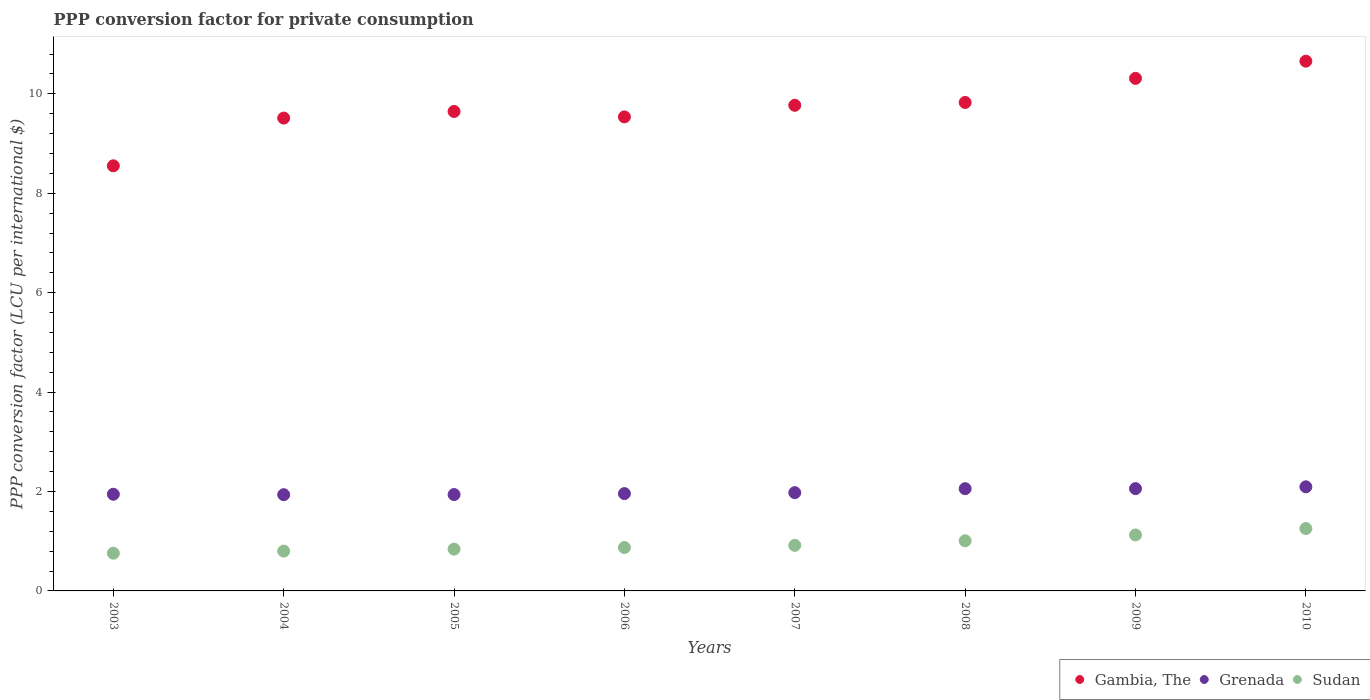How many different coloured dotlines are there?
Your answer should be compact. 3. Is the number of dotlines equal to the number of legend labels?
Offer a very short reply. Yes. What is the PPP conversion factor for private consumption in Sudan in 2008?
Provide a short and direct response. 1.01. Across all years, what is the maximum PPP conversion factor for private consumption in Gambia, The?
Offer a very short reply. 10.66. Across all years, what is the minimum PPP conversion factor for private consumption in Sudan?
Provide a short and direct response. 0.76. In which year was the PPP conversion factor for private consumption in Sudan minimum?
Your answer should be very brief. 2003. What is the total PPP conversion factor for private consumption in Grenada in the graph?
Give a very brief answer. 15.96. What is the difference between the PPP conversion factor for private consumption in Sudan in 2005 and that in 2008?
Your answer should be compact. -0.17. What is the difference between the PPP conversion factor for private consumption in Sudan in 2004 and the PPP conversion factor for private consumption in Grenada in 2008?
Your response must be concise. -1.26. What is the average PPP conversion factor for private consumption in Grenada per year?
Offer a very short reply. 2. In the year 2006, what is the difference between the PPP conversion factor for private consumption in Grenada and PPP conversion factor for private consumption in Sudan?
Your response must be concise. 1.08. What is the ratio of the PPP conversion factor for private consumption in Gambia, The in 2007 to that in 2010?
Ensure brevity in your answer.  0.92. Is the PPP conversion factor for private consumption in Grenada in 2008 less than that in 2010?
Your answer should be compact. Yes. What is the difference between the highest and the second highest PPP conversion factor for private consumption in Sudan?
Offer a terse response. 0.13. What is the difference between the highest and the lowest PPP conversion factor for private consumption in Grenada?
Make the answer very short. 0.16. Does the PPP conversion factor for private consumption in Grenada monotonically increase over the years?
Make the answer very short. No. How many dotlines are there?
Your response must be concise. 3. What is the difference between two consecutive major ticks on the Y-axis?
Ensure brevity in your answer.  2. Does the graph contain any zero values?
Your answer should be very brief. No. How many legend labels are there?
Offer a very short reply. 3. What is the title of the graph?
Provide a short and direct response. PPP conversion factor for private consumption. What is the label or title of the Y-axis?
Offer a terse response. PPP conversion factor (LCU per international $). What is the PPP conversion factor (LCU per international $) of Gambia, The in 2003?
Provide a short and direct response. 8.55. What is the PPP conversion factor (LCU per international $) in Grenada in 2003?
Your response must be concise. 1.94. What is the PPP conversion factor (LCU per international $) of Sudan in 2003?
Your answer should be very brief. 0.76. What is the PPP conversion factor (LCU per international $) in Gambia, The in 2004?
Offer a terse response. 9.51. What is the PPP conversion factor (LCU per international $) of Grenada in 2004?
Your answer should be very brief. 1.94. What is the PPP conversion factor (LCU per international $) in Sudan in 2004?
Give a very brief answer. 0.8. What is the PPP conversion factor (LCU per international $) in Gambia, The in 2005?
Provide a short and direct response. 9.65. What is the PPP conversion factor (LCU per international $) in Grenada in 2005?
Your answer should be very brief. 1.94. What is the PPP conversion factor (LCU per international $) in Sudan in 2005?
Your response must be concise. 0.84. What is the PPP conversion factor (LCU per international $) of Gambia, The in 2006?
Provide a succinct answer. 9.54. What is the PPP conversion factor (LCU per international $) in Grenada in 2006?
Offer a very short reply. 1.96. What is the PPP conversion factor (LCU per international $) in Sudan in 2006?
Provide a succinct answer. 0.87. What is the PPP conversion factor (LCU per international $) in Gambia, The in 2007?
Your response must be concise. 9.77. What is the PPP conversion factor (LCU per international $) of Grenada in 2007?
Your response must be concise. 1.98. What is the PPP conversion factor (LCU per international $) of Sudan in 2007?
Offer a very short reply. 0.92. What is the PPP conversion factor (LCU per international $) of Gambia, The in 2008?
Your answer should be very brief. 9.83. What is the PPP conversion factor (LCU per international $) in Grenada in 2008?
Offer a terse response. 2.06. What is the PPP conversion factor (LCU per international $) of Sudan in 2008?
Your response must be concise. 1.01. What is the PPP conversion factor (LCU per international $) in Gambia, The in 2009?
Ensure brevity in your answer.  10.31. What is the PPP conversion factor (LCU per international $) of Grenada in 2009?
Your response must be concise. 2.06. What is the PPP conversion factor (LCU per international $) in Sudan in 2009?
Your answer should be compact. 1.13. What is the PPP conversion factor (LCU per international $) in Gambia, The in 2010?
Keep it short and to the point. 10.66. What is the PPP conversion factor (LCU per international $) in Grenada in 2010?
Provide a succinct answer. 2.09. What is the PPP conversion factor (LCU per international $) in Sudan in 2010?
Offer a terse response. 1.25. Across all years, what is the maximum PPP conversion factor (LCU per international $) in Gambia, The?
Give a very brief answer. 10.66. Across all years, what is the maximum PPP conversion factor (LCU per international $) in Grenada?
Provide a short and direct response. 2.09. Across all years, what is the maximum PPP conversion factor (LCU per international $) of Sudan?
Provide a short and direct response. 1.25. Across all years, what is the minimum PPP conversion factor (LCU per international $) of Gambia, The?
Provide a succinct answer. 8.55. Across all years, what is the minimum PPP conversion factor (LCU per international $) in Grenada?
Provide a short and direct response. 1.94. Across all years, what is the minimum PPP conversion factor (LCU per international $) in Sudan?
Your answer should be compact. 0.76. What is the total PPP conversion factor (LCU per international $) of Gambia, The in the graph?
Make the answer very short. 77.81. What is the total PPP conversion factor (LCU per international $) of Grenada in the graph?
Give a very brief answer. 15.96. What is the total PPP conversion factor (LCU per international $) in Sudan in the graph?
Your answer should be very brief. 7.58. What is the difference between the PPP conversion factor (LCU per international $) of Gambia, The in 2003 and that in 2004?
Offer a terse response. -0.96. What is the difference between the PPP conversion factor (LCU per international $) in Grenada in 2003 and that in 2004?
Provide a succinct answer. 0.01. What is the difference between the PPP conversion factor (LCU per international $) in Sudan in 2003 and that in 2004?
Make the answer very short. -0.04. What is the difference between the PPP conversion factor (LCU per international $) of Gambia, The in 2003 and that in 2005?
Your answer should be very brief. -1.09. What is the difference between the PPP conversion factor (LCU per international $) in Grenada in 2003 and that in 2005?
Provide a succinct answer. 0.01. What is the difference between the PPP conversion factor (LCU per international $) in Sudan in 2003 and that in 2005?
Your answer should be very brief. -0.08. What is the difference between the PPP conversion factor (LCU per international $) of Gambia, The in 2003 and that in 2006?
Ensure brevity in your answer.  -0.98. What is the difference between the PPP conversion factor (LCU per international $) of Grenada in 2003 and that in 2006?
Offer a terse response. -0.01. What is the difference between the PPP conversion factor (LCU per international $) of Sudan in 2003 and that in 2006?
Offer a very short reply. -0.11. What is the difference between the PPP conversion factor (LCU per international $) of Gambia, The in 2003 and that in 2007?
Your answer should be compact. -1.22. What is the difference between the PPP conversion factor (LCU per international $) in Grenada in 2003 and that in 2007?
Keep it short and to the point. -0.03. What is the difference between the PPP conversion factor (LCU per international $) in Sudan in 2003 and that in 2007?
Offer a terse response. -0.16. What is the difference between the PPP conversion factor (LCU per international $) in Gambia, The in 2003 and that in 2008?
Keep it short and to the point. -1.27. What is the difference between the PPP conversion factor (LCU per international $) in Grenada in 2003 and that in 2008?
Offer a terse response. -0.11. What is the difference between the PPP conversion factor (LCU per international $) of Sudan in 2003 and that in 2008?
Provide a succinct answer. -0.25. What is the difference between the PPP conversion factor (LCU per international $) of Gambia, The in 2003 and that in 2009?
Give a very brief answer. -1.76. What is the difference between the PPP conversion factor (LCU per international $) in Grenada in 2003 and that in 2009?
Make the answer very short. -0.11. What is the difference between the PPP conversion factor (LCU per international $) of Sudan in 2003 and that in 2009?
Offer a terse response. -0.37. What is the difference between the PPP conversion factor (LCU per international $) in Gambia, The in 2003 and that in 2010?
Keep it short and to the point. -2.1. What is the difference between the PPP conversion factor (LCU per international $) of Grenada in 2003 and that in 2010?
Keep it short and to the point. -0.15. What is the difference between the PPP conversion factor (LCU per international $) in Sudan in 2003 and that in 2010?
Offer a very short reply. -0.5. What is the difference between the PPP conversion factor (LCU per international $) of Gambia, The in 2004 and that in 2005?
Offer a very short reply. -0.13. What is the difference between the PPP conversion factor (LCU per international $) of Grenada in 2004 and that in 2005?
Offer a terse response. -0. What is the difference between the PPP conversion factor (LCU per international $) in Sudan in 2004 and that in 2005?
Ensure brevity in your answer.  -0.04. What is the difference between the PPP conversion factor (LCU per international $) in Gambia, The in 2004 and that in 2006?
Keep it short and to the point. -0.02. What is the difference between the PPP conversion factor (LCU per international $) in Grenada in 2004 and that in 2006?
Keep it short and to the point. -0.02. What is the difference between the PPP conversion factor (LCU per international $) of Sudan in 2004 and that in 2006?
Your answer should be very brief. -0.07. What is the difference between the PPP conversion factor (LCU per international $) in Gambia, The in 2004 and that in 2007?
Your answer should be very brief. -0.26. What is the difference between the PPP conversion factor (LCU per international $) in Grenada in 2004 and that in 2007?
Ensure brevity in your answer.  -0.04. What is the difference between the PPP conversion factor (LCU per international $) in Sudan in 2004 and that in 2007?
Your answer should be compact. -0.12. What is the difference between the PPP conversion factor (LCU per international $) of Gambia, The in 2004 and that in 2008?
Your answer should be very brief. -0.31. What is the difference between the PPP conversion factor (LCU per international $) in Grenada in 2004 and that in 2008?
Provide a short and direct response. -0.12. What is the difference between the PPP conversion factor (LCU per international $) of Sudan in 2004 and that in 2008?
Provide a succinct answer. -0.21. What is the difference between the PPP conversion factor (LCU per international $) of Gambia, The in 2004 and that in 2009?
Offer a terse response. -0.8. What is the difference between the PPP conversion factor (LCU per international $) in Grenada in 2004 and that in 2009?
Offer a very short reply. -0.12. What is the difference between the PPP conversion factor (LCU per international $) in Sudan in 2004 and that in 2009?
Provide a succinct answer. -0.33. What is the difference between the PPP conversion factor (LCU per international $) in Gambia, The in 2004 and that in 2010?
Your response must be concise. -1.14. What is the difference between the PPP conversion factor (LCU per international $) of Grenada in 2004 and that in 2010?
Your answer should be very brief. -0.16. What is the difference between the PPP conversion factor (LCU per international $) in Sudan in 2004 and that in 2010?
Your answer should be very brief. -0.45. What is the difference between the PPP conversion factor (LCU per international $) of Gambia, The in 2005 and that in 2006?
Make the answer very short. 0.11. What is the difference between the PPP conversion factor (LCU per international $) of Grenada in 2005 and that in 2006?
Your response must be concise. -0.02. What is the difference between the PPP conversion factor (LCU per international $) of Sudan in 2005 and that in 2006?
Keep it short and to the point. -0.03. What is the difference between the PPP conversion factor (LCU per international $) in Gambia, The in 2005 and that in 2007?
Provide a succinct answer. -0.12. What is the difference between the PPP conversion factor (LCU per international $) in Grenada in 2005 and that in 2007?
Provide a succinct answer. -0.04. What is the difference between the PPP conversion factor (LCU per international $) in Sudan in 2005 and that in 2007?
Provide a short and direct response. -0.08. What is the difference between the PPP conversion factor (LCU per international $) in Gambia, The in 2005 and that in 2008?
Your answer should be compact. -0.18. What is the difference between the PPP conversion factor (LCU per international $) of Grenada in 2005 and that in 2008?
Your answer should be compact. -0.12. What is the difference between the PPP conversion factor (LCU per international $) in Sudan in 2005 and that in 2008?
Give a very brief answer. -0.17. What is the difference between the PPP conversion factor (LCU per international $) in Gambia, The in 2005 and that in 2009?
Give a very brief answer. -0.67. What is the difference between the PPP conversion factor (LCU per international $) of Grenada in 2005 and that in 2009?
Your response must be concise. -0.12. What is the difference between the PPP conversion factor (LCU per international $) in Sudan in 2005 and that in 2009?
Your answer should be compact. -0.29. What is the difference between the PPP conversion factor (LCU per international $) of Gambia, The in 2005 and that in 2010?
Offer a very short reply. -1.01. What is the difference between the PPP conversion factor (LCU per international $) of Grenada in 2005 and that in 2010?
Keep it short and to the point. -0.16. What is the difference between the PPP conversion factor (LCU per international $) in Sudan in 2005 and that in 2010?
Give a very brief answer. -0.41. What is the difference between the PPP conversion factor (LCU per international $) in Gambia, The in 2006 and that in 2007?
Provide a short and direct response. -0.23. What is the difference between the PPP conversion factor (LCU per international $) in Grenada in 2006 and that in 2007?
Your answer should be compact. -0.02. What is the difference between the PPP conversion factor (LCU per international $) of Sudan in 2006 and that in 2007?
Your answer should be very brief. -0.04. What is the difference between the PPP conversion factor (LCU per international $) of Gambia, The in 2006 and that in 2008?
Ensure brevity in your answer.  -0.29. What is the difference between the PPP conversion factor (LCU per international $) of Grenada in 2006 and that in 2008?
Provide a succinct answer. -0.1. What is the difference between the PPP conversion factor (LCU per international $) of Sudan in 2006 and that in 2008?
Make the answer very short. -0.14. What is the difference between the PPP conversion factor (LCU per international $) of Gambia, The in 2006 and that in 2009?
Your answer should be compact. -0.78. What is the difference between the PPP conversion factor (LCU per international $) in Grenada in 2006 and that in 2009?
Ensure brevity in your answer.  -0.1. What is the difference between the PPP conversion factor (LCU per international $) of Sudan in 2006 and that in 2009?
Your response must be concise. -0.25. What is the difference between the PPP conversion factor (LCU per international $) of Gambia, The in 2006 and that in 2010?
Ensure brevity in your answer.  -1.12. What is the difference between the PPP conversion factor (LCU per international $) in Grenada in 2006 and that in 2010?
Ensure brevity in your answer.  -0.14. What is the difference between the PPP conversion factor (LCU per international $) of Sudan in 2006 and that in 2010?
Provide a short and direct response. -0.38. What is the difference between the PPP conversion factor (LCU per international $) of Gambia, The in 2007 and that in 2008?
Your answer should be very brief. -0.06. What is the difference between the PPP conversion factor (LCU per international $) in Grenada in 2007 and that in 2008?
Your answer should be compact. -0.08. What is the difference between the PPP conversion factor (LCU per international $) of Sudan in 2007 and that in 2008?
Your answer should be very brief. -0.09. What is the difference between the PPP conversion factor (LCU per international $) in Gambia, The in 2007 and that in 2009?
Offer a very short reply. -0.54. What is the difference between the PPP conversion factor (LCU per international $) in Grenada in 2007 and that in 2009?
Your answer should be compact. -0.08. What is the difference between the PPP conversion factor (LCU per international $) of Sudan in 2007 and that in 2009?
Give a very brief answer. -0.21. What is the difference between the PPP conversion factor (LCU per international $) in Gambia, The in 2007 and that in 2010?
Make the answer very short. -0.89. What is the difference between the PPP conversion factor (LCU per international $) of Grenada in 2007 and that in 2010?
Your answer should be very brief. -0.12. What is the difference between the PPP conversion factor (LCU per international $) of Sudan in 2007 and that in 2010?
Your response must be concise. -0.34. What is the difference between the PPP conversion factor (LCU per international $) of Gambia, The in 2008 and that in 2009?
Provide a short and direct response. -0.48. What is the difference between the PPP conversion factor (LCU per international $) in Grenada in 2008 and that in 2009?
Your response must be concise. -0. What is the difference between the PPP conversion factor (LCU per international $) of Sudan in 2008 and that in 2009?
Keep it short and to the point. -0.12. What is the difference between the PPP conversion factor (LCU per international $) of Gambia, The in 2008 and that in 2010?
Ensure brevity in your answer.  -0.83. What is the difference between the PPP conversion factor (LCU per international $) of Grenada in 2008 and that in 2010?
Make the answer very short. -0.04. What is the difference between the PPP conversion factor (LCU per international $) in Sudan in 2008 and that in 2010?
Offer a very short reply. -0.25. What is the difference between the PPP conversion factor (LCU per international $) in Gambia, The in 2009 and that in 2010?
Make the answer very short. -0.35. What is the difference between the PPP conversion factor (LCU per international $) of Grenada in 2009 and that in 2010?
Ensure brevity in your answer.  -0.04. What is the difference between the PPP conversion factor (LCU per international $) in Sudan in 2009 and that in 2010?
Make the answer very short. -0.13. What is the difference between the PPP conversion factor (LCU per international $) of Gambia, The in 2003 and the PPP conversion factor (LCU per international $) of Grenada in 2004?
Make the answer very short. 6.62. What is the difference between the PPP conversion factor (LCU per international $) in Gambia, The in 2003 and the PPP conversion factor (LCU per international $) in Sudan in 2004?
Provide a short and direct response. 7.75. What is the difference between the PPP conversion factor (LCU per international $) of Grenada in 2003 and the PPP conversion factor (LCU per international $) of Sudan in 2004?
Provide a succinct answer. 1.14. What is the difference between the PPP conversion factor (LCU per international $) of Gambia, The in 2003 and the PPP conversion factor (LCU per international $) of Grenada in 2005?
Your response must be concise. 6.61. What is the difference between the PPP conversion factor (LCU per international $) in Gambia, The in 2003 and the PPP conversion factor (LCU per international $) in Sudan in 2005?
Make the answer very short. 7.71. What is the difference between the PPP conversion factor (LCU per international $) of Grenada in 2003 and the PPP conversion factor (LCU per international $) of Sudan in 2005?
Ensure brevity in your answer.  1.1. What is the difference between the PPP conversion factor (LCU per international $) of Gambia, The in 2003 and the PPP conversion factor (LCU per international $) of Grenada in 2006?
Ensure brevity in your answer.  6.59. What is the difference between the PPP conversion factor (LCU per international $) of Gambia, The in 2003 and the PPP conversion factor (LCU per international $) of Sudan in 2006?
Your answer should be very brief. 7.68. What is the difference between the PPP conversion factor (LCU per international $) in Grenada in 2003 and the PPP conversion factor (LCU per international $) in Sudan in 2006?
Offer a terse response. 1.07. What is the difference between the PPP conversion factor (LCU per international $) in Gambia, The in 2003 and the PPP conversion factor (LCU per international $) in Grenada in 2007?
Your answer should be very brief. 6.58. What is the difference between the PPP conversion factor (LCU per international $) of Gambia, The in 2003 and the PPP conversion factor (LCU per international $) of Sudan in 2007?
Provide a succinct answer. 7.64. What is the difference between the PPP conversion factor (LCU per international $) of Grenada in 2003 and the PPP conversion factor (LCU per international $) of Sudan in 2007?
Provide a short and direct response. 1.03. What is the difference between the PPP conversion factor (LCU per international $) of Gambia, The in 2003 and the PPP conversion factor (LCU per international $) of Grenada in 2008?
Offer a terse response. 6.5. What is the difference between the PPP conversion factor (LCU per international $) in Gambia, The in 2003 and the PPP conversion factor (LCU per international $) in Sudan in 2008?
Ensure brevity in your answer.  7.54. What is the difference between the PPP conversion factor (LCU per international $) of Grenada in 2003 and the PPP conversion factor (LCU per international $) of Sudan in 2008?
Provide a succinct answer. 0.94. What is the difference between the PPP conversion factor (LCU per international $) in Gambia, The in 2003 and the PPP conversion factor (LCU per international $) in Grenada in 2009?
Your response must be concise. 6.49. What is the difference between the PPP conversion factor (LCU per international $) of Gambia, The in 2003 and the PPP conversion factor (LCU per international $) of Sudan in 2009?
Offer a terse response. 7.43. What is the difference between the PPP conversion factor (LCU per international $) of Grenada in 2003 and the PPP conversion factor (LCU per international $) of Sudan in 2009?
Give a very brief answer. 0.82. What is the difference between the PPP conversion factor (LCU per international $) of Gambia, The in 2003 and the PPP conversion factor (LCU per international $) of Grenada in 2010?
Offer a very short reply. 6.46. What is the difference between the PPP conversion factor (LCU per international $) in Gambia, The in 2003 and the PPP conversion factor (LCU per international $) in Sudan in 2010?
Your answer should be compact. 7.3. What is the difference between the PPP conversion factor (LCU per international $) in Grenada in 2003 and the PPP conversion factor (LCU per international $) in Sudan in 2010?
Keep it short and to the point. 0.69. What is the difference between the PPP conversion factor (LCU per international $) of Gambia, The in 2004 and the PPP conversion factor (LCU per international $) of Grenada in 2005?
Your response must be concise. 7.57. What is the difference between the PPP conversion factor (LCU per international $) of Gambia, The in 2004 and the PPP conversion factor (LCU per international $) of Sudan in 2005?
Your response must be concise. 8.67. What is the difference between the PPP conversion factor (LCU per international $) of Grenada in 2004 and the PPP conversion factor (LCU per international $) of Sudan in 2005?
Keep it short and to the point. 1.1. What is the difference between the PPP conversion factor (LCU per international $) in Gambia, The in 2004 and the PPP conversion factor (LCU per international $) in Grenada in 2006?
Make the answer very short. 7.55. What is the difference between the PPP conversion factor (LCU per international $) of Gambia, The in 2004 and the PPP conversion factor (LCU per international $) of Sudan in 2006?
Ensure brevity in your answer.  8.64. What is the difference between the PPP conversion factor (LCU per international $) in Grenada in 2004 and the PPP conversion factor (LCU per international $) in Sudan in 2006?
Ensure brevity in your answer.  1.06. What is the difference between the PPP conversion factor (LCU per international $) of Gambia, The in 2004 and the PPP conversion factor (LCU per international $) of Grenada in 2007?
Your answer should be very brief. 7.54. What is the difference between the PPP conversion factor (LCU per international $) of Gambia, The in 2004 and the PPP conversion factor (LCU per international $) of Sudan in 2007?
Your answer should be very brief. 8.6. What is the difference between the PPP conversion factor (LCU per international $) in Grenada in 2004 and the PPP conversion factor (LCU per international $) in Sudan in 2007?
Your answer should be compact. 1.02. What is the difference between the PPP conversion factor (LCU per international $) in Gambia, The in 2004 and the PPP conversion factor (LCU per international $) in Grenada in 2008?
Your response must be concise. 7.46. What is the difference between the PPP conversion factor (LCU per international $) in Gambia, The in 2004 and the PPP conversion factor (LCU per international $) in Sudan in 2008?
Provide a succinct answer. 8.5. What is the difference between the PPP conversion factor (LCU per international $) of Grenada in 2004 and the PPP conversion factor (LCU per international $) of Sudan in 2008?
Make the answer very short. 0.93. What is the difference between the PPP conversion factor (LCU per international $) in Gambia, The in 2004 and the PPP conversion factor (LCU per international $) in Grenada in 2009?
Your response must be concise. 7.45. What is the difference between the PPP conversion factor (LCU per international $) in Gambia, The in 2004 and the PPP conversion factor (LCU per international $) in Sudan in 2009?
Provide a succinct answer. 8.39. What is the difference between the PPP conversion factor (LCU per international $) in Grenada in 2004 and the PPP conversion factor (LCU per international $) in Sudan in 2009?
Your answer should be very brief. 0.81. What is the difference between the PPP conversion factor (LCU per international $) of Gambia, The in 2004 and the PPP conversion factor (LCU per international $) of Grenada in 2010?
Ensure brevity in your answer.  7.42. What is the difference between the PPP conversion factor (LCU per international $) of Gambia, The in 2004 and the PPP conversion factor (LCU per international $) of Sudan in 2010?
Give a very brief answer. 8.26. What is the difference between the PPP conversion factor (LCU per international $) of Grenada in 2004 and the PPP conversion factor (LCU per international $) of Sudan in 2010?
Offer a terse response. 0.68. What is the difference between the PPP conversion factor (LCU per international $) of Gambia, The in 2005 and the PPP conversion factor (LCU per international $) of Grenada in 2006?
Ensure brevity in your answer.  7.69. What is the difference between the PPP conversion factor (LCU per international $) in Gambia, The in 2005 and the PPP conversion factor (LCU per international $) in Sudan in 2006?
Keep it short and to the point. 8.77. What is the difference between the PPP conversion factor (LCU per international $) in Grenada in 2005 and the PPP conversion factor (LCU per international $) in Sudan in 2006?
Keep it short and to the point. 1.07. What is the difference between the PPP conversion factor (LCU per international $) of Gambia, The in 2005 and the PPP conversion factor (LCU per international $) of Grenada in 2007?
Your response must be concise. 7.67. What is the difference between the PPP conversion factor (LCU per international $) of Gambia, The in 2005 and the PPP conversion factor (LCU per international $) of Sudan in 2007?
Make the answer very short. 8.73. What is the difference between the PPP conversion factor (LCU per international $) in Grenada in 2005 and the PPP conversion factor (LCU per international $) in Sudan in 2007?
Your answer should be compact. 1.02. What is the difference between the PPP conversion factor (LCU per international $) of Gambia, The in 2005 and the PPP conversion factor (LCU per international $) of Grenada in 2008?
Provide a short and direct response. 7.59. What is the difference between the PPP conversion factor (LCU per international $) in Gambia, The in 2005 and the PPP conversion factor (LCU per international $) in Sudan in 2008?
Ensure brevity in your answer.  8.64. What is the difference between the PPP conversion factor (LCU per international $) of Grenada in 2005 and the PPP conversion factor (LCU per international $) of Sudan in 2008?
Your answer should be compact. 0.93. What is the difference between the PPP conversion factor (LCU per international $) of Gambia, The in 2005 and the PPP conversion factor (LCU per international $) of Grenada in 2009?
Provide a short and direct response. 7.59. What is the difference between the PPP conversion factor (LCU per international $) in Gambia, The in 2005 and the PPP conversion factor (LCU per international $) in Sudan in 2009?
Your answer should be very brief. 8.52. What is the difference between the PPP conversion factor (LCU per international $) of Grenada in 2005 and the PPP conversion factor (LCU per international $) of Sudan in 2009?
Provide a short and direct response. 0.81. What is the difference between the PPP conversion factor (LCU per international $) of Gambia, The in 2005 and the PPP conversion factor (LCU per international $) of Grenada in 2010?
Give a very brief answer. 7.55. What is the difference between the PPP conversion factor (LCU per international $) of Gambia, The in 2005 and the PPP conversion factor (LCU per international $) of Sudan in 2010?
Ensure brevity in your answer.  8.39. What is the difference between the PPP conversion factor (LCU per international $) in Grenada in 2005 and the PPP conversion factor (LCU per international $) in Sudan in 2010?
Make the answer very short. 0.68. What is the difference between the PPP conversion factor (LCU per international $) of Gambia, The in 2006 and the PPP conversion factor (LCU per international $) of Grenada in 2007?
Make the answer very short. 7.56. What is the difference between the PPP conversion factor (LCU per international $) of Gambia, The in 2006 and the PPP conversion factor (LCU per international $) of Sudan in 2007?
Provide a succinct answer. 8.62. What is the difference between the PPP conversion factor (LCU per international $) of Grenada in 2006 and the PPP conversion factor (LCU per international $) of Sudan in 2007?
Your response must be concise. 1.04. What is the difference between the PPP conversion factor (LCU per international $) of Gambia, The in 2006 and the PPP conversion factor (LCU per international $) of Grenada in 2008?
Your answer should be very brief. 7.48. What is the difference between the PPP conversion factor (LCU per international $) in Gambia, The in 2006 and the PPP conversion factor (LCU per international $) in Sudan in 2008?
Offer a very short reply. 8.53. What is the difference between the PPP conversion factor (LCU per international $) of Grenada in 2006 and the PPP conversion factor (LCU per international $) of Sudan in 2008?
Offer a terse response. 0.95. What is the difference between the PPP conversion factor (LCU per international $) of Gambia, The in 2006 and the PPP conversion factor (LCU per international $) of Grenada in 2009?
Provide a short and direct response. 7.48. What is the difference between the PPP conversion factor (LCU per international $) in Gambia, The in 2006 and the PPP conversion factor (LCU per international $) in Sudan in 2009?
Provide a short and direct response. 8.41. What is the difference between the PPP conversion factor (LCU per international $) of Grenada in 2006 and the PPP conversion factor (LCU per international $) of Sudan in 2009?
Offer a terse response. 0.83. What is the difference between the PPP conversion factor (LCU per international $) in Gambia, The in 2006 and the PPP conversion factor (LCU per international $) in Grenada in 2010?
Keep it short and to the point. 7.44. What is the difference between the PPP conversion factor (LCU per international $) in Gambia, The in 2006 and the PPP conversion factor (LCU per international $) in Sudan in 2010?
Give a very brief answer. 8.28. What is the difference between the PPP conversion factor (LCU per international $) in Grenada in 2006 and the PPP conversion factor (LCU per international $) in Sudan in 2010?
Your answer should be very brief. 0.7. What is the difference between the PPP conversion factor (LCU per international $) of Gambia, The in 2007 and the PPP conversion factor (LCU per international $) of Grenada in 2008?
Offer a terse response. 7.71. What is the difference between the PPP conversion factor (LCU per international $) of Gambia, The in 2007 and the PPP conversion factor (LCU per international $) of Sudan in 2008?
Make the answer very short. 8.76. What is the difference between the PPP conversion factor (LCU per international $) of Grenada in 2007 and the PPP conversion factor (LCU per international $) of Sudan in 2008?
Offer a terse response. 0.97. What is the difference between the PPP conversion factor (LCU per international $) in Gambia, The in 2007 and the PPP conversion factor (LCU per international $) in Grenada in 2009?
Your answer should be very brief. 7.71. What is the difference between the PPP conversion factor (LCU per international $) of Gambia, The in 2007 and the PPP conversion factor (LCU per international $) of Sudan in 2009?
Offer a very short reply. 8.64. What is the difference between the PPP conversion factor (LCU per international $) in Grenada in 2007 and the PPP conversion factor (LCU per international $) in Sudan in 2009?
Your response must be concise. 0.85. What is the difference between the PPP conversion factor (LCU per international $) of Gambia, The in 2007 and the PPP conversion factor (LCU per international $) of Grenada in 2010?
Give a very brief answer. 7.68. What is the difference between the PPP conversion factor (LCU per international $) in Gambia, The in 2007 and the PPP conversion factor (LCU per international $) in Sudan in 2010?
Make the answer very short. 8.51. What is the difference between the PPP conversion factor (LCU per international $) of Grenada in 2007 and the PPP conversion factor (LCU per international $) of Sudan in 2010?
Provide a succinct answer. 0.72. What is the difference between the PPP conversion factor (LCU per international $) in Gambia, The in 2008 and the PPP conversion factor (LCU per international $) in Grenada in 2009?
Offer a terse response. 7.77. What is the difference between the PPP conversion factor (LCU per international $) of Gambia, The in 2008 and the PPP conversion factor (LCU per international $) of Sudan in 2009?
Provide a short and direct response. 8.7. What is the difference between the PPP conversion factor (LCU per international $) in Grenada in 2008 and the PPP conversion factor (LCU per international $) in Sudan in 2009?
Provide a short and direct response. 0.93. What is the difference between the PPP conversion factor (LCU per international $) of Gambia, The in 2008 and the PPP conversion factor (LCU per international $) of Grenada in 2010?
Your answer should be very brief. 7.73. What is the difference between the PPP conversion factor (LCU per international $) in Gambia, The in 2008 and the PPP conversion factor (LCU per international $) in Sudan in 2010?
Ensure brevity in your answer.  8.57. What is the difference between the PPP conversion factor (LCU per international $) in Grenada in 2008 and the PPP conversion factor (LCU per international $) in Sudan in 2010?
Keep it short and to the point. 0.8. What is the difference between the PPP conversion factor (LCU per international $) of Gambia, The in 2009 and the PPP conversion factor (LCU per international $) of Grenada in 2010?
Your answer should be very brief. 8.22. What is the difference between the PPP conversion factor (LCU per international $) in Gambia, The in 2009 and the PPP conversion factor (LCU per international $) in Sudan in 2010?
Your answer should be compact. 9.06. What is the difference between the PPP conversion factor (LCU per international $) of Grenada in 2009 and the PPP conversion factor (LCU per international $) of Sudan in 2010?
Provide a short and direct response. 0.8. What is the average PPP conversion factor (LCU per international $) of Gambia, The per year?
Your response must be concise. 9.73. What is the average PPP conversion factor (LCU per international $) of Grenada per year?
Keep it short and to the point. 2. What is the average PPP conversion factor (LCU per international $) of Sudan per year?
Offer a very short reply. 0.95. In the year 2003, what is the difference between the PPP conversion factor (LCU per international $) in Gambia, The and PPP conversion factor (LCU per international $) in Grenada?
Give a very brief answer. 6.61. In the year 2003, what is the difference between the PPP conversion factor (LCU per international $) in Gambia, The and PPP conversion factor (LCU per international $) in Sudan?
Ensure brevity in your answer.  7.79. In the year 2003, what is the difference between the PPP conversion factor (LCU per international $) of Grenada and PPP conversion factor (LCU per international $) of Sudan?
Your response must be concise. 1.19. In the year 2004, what is the difference between the PPP conversion factor (LCU per international $) in Gambia, The and PPP conversion factor (LCU per international $) in Grenada?
Keep it short and to the point. 7.58. In the year 2004, what is the difference between the PPP conversion factor (LCU per international $) in Gambia, The and PPP conversion factor (LCU per international $) in Sudan?
Make the answer very short. 8.71. In the year 2004, what is the difference between the PPP conversion factor (LCU per international $) in Grenada and PPP conversion factor (LCU per international $) in Sudan?
Give a very brief answer. 1.14. In the year 2005, what is the difference between the PPP conversion factor (LCU per international $) in Gambia, The and PPP conversion factor (LCU per international $) in Grenada?
Ensure brevity in your answer.  7.71. In the year 2005, what is the difference between the PPP conversion factor (LCU per international $) in Gambia, The and PPP conversion factor (LCU per international $) in Sudan?
Make the answer very short. 8.8. In the year 2005, what is the difference between the PPP conversion factor (LCU per international $) in Grenada and PPP conversion factor (LCU per international $) in Sudan?
Your response must be concise. 1.1. In the year 2006, what is the difference between the PPP conversion factor (LCU per international $) in Gambia, The and PPP conversion factor (LCU per international $) in Grenada?
Ensure brevity in your answer.  7.58. In the year 2006, what is the difference between the PPP conversion factor (LCU per international $) of Gambia, The and PPP conversion factor (LCU per international $) of Sudan?
Offer a terse response. 8.66. In the year 2006, what is the difference between the PPP conversion factor (LCU per international $) of Grenada and PPP conversion factor (LCU per international $) of Sudan?
Provide a succinct answer. 1.08. In the year 2007, what is the difference between the PPP conversion factor (LCU per international $) of Gambia, The and PPP conversion factor (LCU per international $) of Grenada?
Offer a terse response. 7.79. In the year 2007, what is the difference between the PPP conversion factor (LCU per international $) in Gambia, The and PPP conversion factor (LCU per international $) in Sudan?
Your answer should be compact. 8.85. In the year 2007, what is the difference between the PPP conversion factor (LCU per international $) in Grenada and PPP conversion factor (LCU per international $) in Sudan?
Keep it short and to the point. 1.06. In the year 2008, what is the difference between the PPP conversion factor (LCU per international $) of Gambia, The and PPP conversion factor (LCU per international $) of Grenada?
Provide a short and direct response. 7.77. In the year 2008, what is the difference between the PPP conversion factor (LCU per international $) of Gambia, The and PPP conversion factor (LCU per international $) of Sudan?
Offer a very short reply. 8.82. In the year 2008, what is the difference between the PPP conversion factor (LCU per international $) of Grenada and PPP conversion factor (LCU per international $) of Sudan?
Give a very brief answer. 1.05. In the year 2009, what is the difference between the PPP conversion factor (LCU per international $) in Gambia, The and PPP conversion factor (LCU per international $) in Grenada?
Keep it short and to the point. 8.25. In the year 2009, what is the difference between the PPP conversion factor (LCU per international $) of Gambia, The and PPP conversion factor (LCU per international $) of Sudan?
Offer a very short reply. 9.18. In the year 2009, what is the difference between the PPP conversion factor (LCU per international $) of Grenada and PPP conversion factor (LCU per international $) of Sudan?
Provide a short and direct response. 0.93. In the year 2010, what is the difference between the PPP conversion factor (LCU per international $) of Gambia, The and PPP conversion factor (LCU per international $) of Grenada?
Make the answer very short. 8.56. In the year 2010, what is the difference between the PPP conversion factor (LCU per international $) in Gambia, The and PPP conversion factor (LCU per international $) in Sudan?
Offer a very short reply. 9.4. In the year 2010, what is the difference between the PPP conversion factor (LCU per international $) of Grenada and PPP conversion factor (LCU per international $) of Sudan?
Keep it short and to the point. 0.84. What is the ratio of the PPP conversion factor (LCU per international $) of Gambia, The in 2003 to that in 2004?
Make the answer very short. 0.9. What is the ratio of the PPP conversion factor (LCU per international $) of Grenada in 2003 to that in 2004?
Make the answer very short. 1. What is the ratio of the PPP conversion factor (LCU per international $) in Sudan in 2003 to that in 2004?
Your response must be concise. 0.95. What is the ratio of the PPP conversion factor (LCU per international $) of Gambia, The in 2003 to that in 2005?
Provide a succinct answer. 0.89. What is the ratio of the PPP conversion factor (LCU per international $) of Grenada in 2003 to that in 2005?
Offer a very short reply. 1. What is the ratio of the PPP conversion factor (LCU per international $) of Sudan in 2003 to that in 2005?
Keep it short and to the point. 0.9. What is the ratio of the PPP conversion factor (LCU per international $) of Gambia, The in 2003 to that in 2006?
Provide a short and direct response. 0.9. What is the ratio of the PPP conversion factor (LCU per international $) of Sudan in 2003 to that in 2006?
Keep it short and to the point. 0.87. What is the ratio of the PPP conversion factor (LCU per international $) of Gambia, The in 2003 to that in 2007?
Make the answer very short. 0.88. What is the ratio of the PPP conversion factor (LCU per international $) in Grenada in 2003 to that in 2007?
Your response must be concise. 0.98. What is the ratio of the PPP conversion factor (LCU per international $) in Sudan in 2003 to that in 2007?
Your answer should be compact. 0.83. What is the ratio of the PPP conversion factor (LCU per international $) of Gambia, The in 2003 to that in 2008?
Give a very brief answer. 0.87. What is the ratio of the PPP conversion factor (LCU per international $) of Grenada in 2003 to that in 2008?
Your answer should be very brief. 0.95. What is the ratio of the PPP conversion factor (LCU per international $) of Sudan in 2003 to that in 2008?
Your response must be concise. 0.75. What is the ratio of the PPP conversion factor (LCU per international $) of Gambia, The in 2003 to that in 2009?
Offer a very short reply. 0.83. What is the ratio of the PPP conversion factor (LCU per international $) in Grenada in 2003 to that in 2009?
Provide a short and direct response. 0.94. What is the ratio of the PPP conversion factor (LCU per international $) in Sudan in 2003 to that in 2009?
Give a very brief answer. 0.67. What is the ratio of the PPP conversion factor (LCU per international $) of Gambia, The in 2003 to that in 2010?
Your answer should be very brief. 0.8. What is the ratio of the PPP conversion factor (LCU per international $) in Grenada in 2003 to that in 2010?
Keep it short and to the point. 0.93. What is the ratio of the PPP conversion factor (LCU per international $) of Sudan in 2003 to that in 2010?
Provide a succinct answer. 0.6. What is the ratio of the PPP conversion factor (LCU per international $) of Gambia, The in 2004 to that in 2005?
Ensure brevity in your answer.  0.99. What is the ratio of the PPP conversion factor (LCU per international $) of Sudan in 2004 to that in 2005?
Your answer should be compact. 0.95. What is the ratio of the PPP conversion factor (LCU per international $) of Grenada in 2004 to that in 2006?
Keep it short and to the point. 0.99. What is the ratio of the PPP conversion factor (LCU per international $) in Sudan in 2004 to that in 2006?
Ensure brevity in your answer.  0.92. What is the ratio of the PPP conversion factor (LCU per international $) of Gambia, The in 2004 to that in 2007?
Ensure brevity in your answer.  0.97. What is the ratio of the PPP conversion factor (LCU per international $) of Grenada in 2004 to that in 2007?
Offer a very short reply. 0.98. What is the ratio of the PPP conversion factor (LCU per international $) in Sudan in 2004 to that in 2007?
Give a very brief answer. 0.87. What is the ratio of the PPP conversion factor (LCU per international $) in Gambia, The in 2004 to that in 2008?
Make the answer very short. 0.97. What is the ratio of the PPP conversion factor (LCU per international $) in Sudan in 2004 to that in 2008?
Give a very brief answer. 0.79. What is the ratio of the PPP conversion factor (LCU per international $) in Gambia, The in 2004 to that in 2009?
Provide a succinct answer. 0.92. What is the ratio of the PPP conversion factor (LCU per international $) in Grenada in 2004 to that in 2009?
Provide a short and direct response. 0.94. What is the ratio of the PPP conversion factor (LCU per international $) of Sudan in 2004 to that in 2009?
Give a very brief answer. 0.71. What is the ratio of the PPP conversion factor (LCU per international $) of Gambia, The in 2004 to that in 2010?
Make the answer very short. 0.89. What is the ratio of the PPP conversion factor (LCU per international $) of Grenada in 2004 to that in 2010?
Give a very brief answer. 0.92. What is the ratio of the PPP conversion factor (LCU per international $) in Sudan in 2004 to that in 2010?
Offer a terse response. 0.64. What is the ratio of the PPP conversion factor (LCU per international $) in Gambia, The in 2005 to that in 2006?
Your response must be concise. 1.01. What is the ratio of the PPP conversion factor (LCU per international $) of Grenada in 2005 to that in 2006?
Provide a short and direct response. 0.99. What is the ratio of the PPP conversion factor (LCU per international $) of Gambia, The in 2005 to that in 2007?
Your answer should be very brief. 0.99. What is the ratio of the PPP conversion factor (LCU per international $) of Grenada in 2005 to that in 2007?
Provide a succinct answer. 0.98. What is the ratio of the PPP conversion factor (LCU per international $) of Sudan in 2005 to that in 2007?
Give a very brief answer. 0.92. What is the ratio of the PPP conversion factor (LCU per international $) of Gambia, The in 2005 to that in 2008?
Your answer should be very brief. 0.98. What is the ratio of the PPP conversion factor (LCU per international $) in Grenada in 2005 to that in 2008?
Provide a short and direct response. 0.94. What is the ratio of the PPP conversion factor (LCU per international $) of Sudan in 2005 to that in 2008?
Your response must be concise. 0.83. What is the ratio of the PPP conversion factor (LCU per international $) in Gambia, The in 2005 to that in 2009?
Your response must be concise. 0.94. What is the ratio of the PPP conversion factor (LCU per international $) in Grenada in 2005 to that in 2009?
Your answer should be very brief. 0.94. What is the ratio of the PPP conversion factor (LCU per international $) in Sudan in 2005 to that in 2009?
Your response must be concise. 0.75. What is the ratio of the PPP conversion factor (LCU per international $) in Gambia, The in 2005 to that in 2010?
Provide a short and direct response. 0.91. What is the ratio of the PPP conversion factor (LCU per international $) of Grenada in 2005 to that in 2010?
Your answer should be very brief. 0.93. What is the ratio of the PPP conversion factor (LCU per international $) in Sudan in 2005 to that in 2010?
Ensure brevity in your answer.  0.67. What is the ratio of the PPP conversion factor (LCU per international $) of Gambia, The in 2006 to that in 2007?
Your answer should be very brief. 0.98. What is the ratio of the PPP conversion factor (LCU per international $) in Grenada in 2006 to that in 2007?
Provide a short and direct response. 0.99. What is the ratio of the PPP conversion factor (LCU per international $) of Sudan in 2006 to that in 2007?
Offer a very short reply. 0.95. What is the ratio of the PPP conversion factor (LCU per international $) of Gambia, The in 2006 to that in 2008?
Offer a very short reply. 0.97. What is the ratio of the PPP conversion factor (LCU per international $) in Grenada in 2006 to that in 2008?
Make the answer very short. 0.95. What is the ratio of the PPP conversion factor (LCU per international $) in Sudan in 2006 to that in 2008?
Make the answer very short. 0.87. What is the ratio of the PPP conversion factor (LCU per international $) of Gambia, The in 2006 to that in 2009?
Ensure brevity in your answer.  0.92. What is the ratio of the PPP conversion factor (LCU per international $) of Grenada in 2006 to that in 2009?
Provide a succinct answer. 0.95. What is the ratio of the PPP conversion factor (LCU per international $) in Sudan in 2006 to that in 2009?
Offer a terse response. 0.78. What is the ratio of the PPP conversion factor (LCU per international $) of Gambia, The in 2006 to that in 2010?
Ensure brevity in your answer.  0.89. What is the ratio of the PPP conversion factor (LCU per international $) of Grenada in 2006 to that in 2010?
Ensure brevity in your answer.  0.93. What is the ratio of the PPP conversion factor (LCU per international $) of Sudan in 2006 to that in 2010?
Make the answer very short. 0.7. What is the ratio of the PPP conversion factor (LCU per international $) in Grenada in 2007 to that in 2008?
Give a very brief answer. 0.96. What is the ratio of the PPP conversion factor (LCU per international $) of Sudan in 2007 to that in 2008?
Provide a succinct answer. 0.91. What is the ratio of the PPP conversion factor (LCU per international $) of Gambia, The in 2007 to that in 2009?
Your answer should be compact. 0.95. What is the ratio of the PPP conversion factor (LCU per international $) in Grenada in 2007 to that in 2009?
Your response must be concise. 0.96. What is the ratio of the PPP conversion factor (LCU per international $) of Sudan in 2007 to that in 2009?
Your response must be concise. 0.81. What is the ratio of the PPP conversion factor (LCU per international $) of Gambia, The in 2007 to that in 2010?
Give a very brief answer. 0.92. What is the ratio of the PPP conversion factor (LCU per international $) in Grenada in 2007 to that in 2010?
Your response must be concise. 0.94. What is the ratio of the PPP conversion factor (LCU per international $) in Sudan in 2007 to that in 2010?
Offer a terse response. 0.73. What is the ratio of the PPP conversion factor (LCU per international $) of Gambia, The in 2008 to that in 2009?
Your answer should be compact. 0.95. What is the ratio of the PPP conversion factor (LCU per international $) of Sudan in 2008 to that in 2009?
Your response must be concise. 0.9. What is the ratio of the PPP conversion factor (LCU per international $) of Gambia, The in 2008 to that in 2010?
Keep it short and to the point. 0.92. What is the ratio of the PPP conversion factor (LCU per international $) of Grenada in 2008 to that in 2010?
Ensure brevity in your answer.  0.98. What is the ratio of the PPP conversion factor (LCU per international $) of Sudan in 2008 to that in 2010?
Give a very brief answer. 0.8. What is the ratio of the PPP conversion factor (LCU per international $) of Gambia, The in 2009 to that in 2010?
Your answer should be compact. 0.97. What is the ratio of the PPP conversion factor (LCU per international $) of Grenada in 2009 to that in 2010?
Make the answer very short. 0.98. What is the ratio of the PPP conversion factor (LCU per international $) of Sudan in 2009 to that in 2010?
Provide a succinct answer. 0.9. What is the difference between the highest and the second highest PPP conversion factor (LCU per international $) of Gambia, The?
Provide a short and direct response. 0.35. What is the difference between the highest and the second highest PPP conversion factor (LCU per international $) of Grenada?
Make the answer very short. 0.04. What is the difference between the highest and the second highest PPP conversion factor (LCU per international $) in Sudan?
Your answer should be compact. 0.13. What is the difference between the highest and the lowest PPP conversion factor (LCU per international $) of Gambia, The?
Offer a terse response. 2.1. What is the difference between the highest and the lowest PPP conversion factor (LCU per international $) in Grenada?
Make the answer very short. 0.16. What is the difference between the highest and the lowest PPP conversion factor (LCU per international $) of Sudan?
Keep it short and to the point. 0.5. 